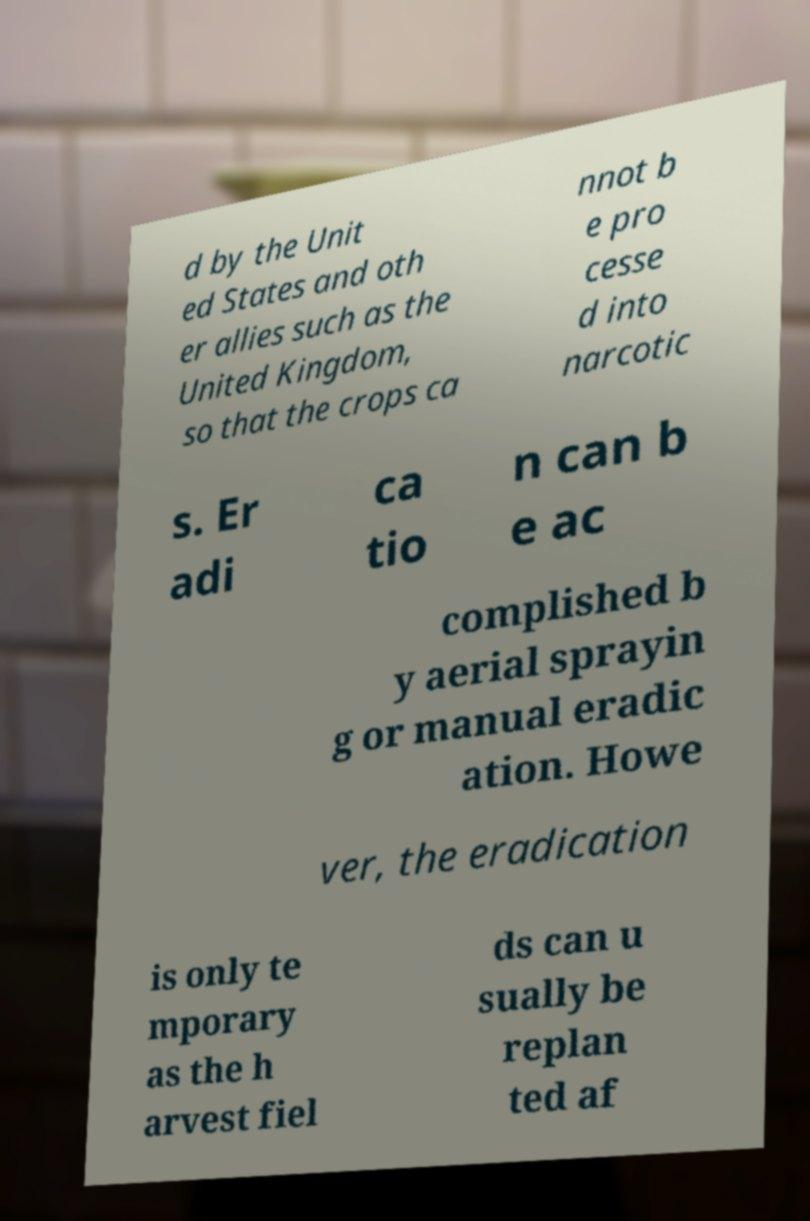Please read and relay the text visible in this image. What does it say? d by the Unit ed States and oth er allies such as the United Kingdom, so that the crops ca nnot b e pro cesse d into narcotic s. Er adi ca tio n can b e ac complished b y aerial sprayin g or manual eradic ation. Howe ver, the eradication is only te mporary as the h arvest fiel ds can u sually be replan ted af 